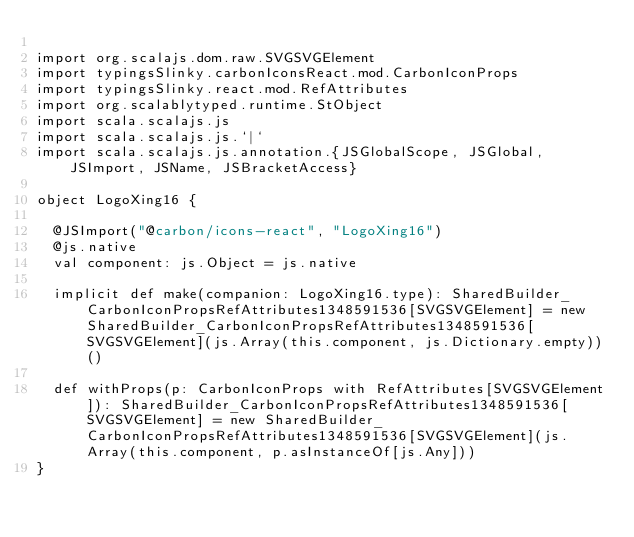Convert code to text. <code><loc_0><loc_0><loc_500><loc_500><_Scala_>
import org.scalajs.dom.raw.SVGSVGElement
import typingsSlinky.carbonIconsReact.mod.CarbonIconProps
import typingsSlinky.react.mod.RefAttributes
import org.scalablytyped.runtime.StObject
import scala.scalajs.js
import scala.scalajs.js.`|`
import scala.scalajs.js.annotation.{JSGlobalScope, JSGlobal, JSImport, JSName, JSBracketAccess}

object LogoXing16 {
  
  @JSImport("@carbon/icons-react", "LogoXing16")
  @js.native
  val component: js.Object = js.native
  
  implicit def make(companion: LogoXing16.type): SharedBuilder_CarbonIconPropsRefAttributes1348591536[SVGSVGElement] = new SharedBuilder_CarbonIconPropsRefAttributes1348591536[SVGSVGElement](js.Array(this.component, js.Dictionary.empty))()
  
  def withProps(p: CarbonIconProps with RefAttributes[SVGSVGElement]): SharedBuilder_CarbonIconPropsRefAttributes1348591536[SVGSVGElement] = new SharedBuilder_CarbonIconPropsRefAttributes1348591536[SVGSVGElement](js.Array(this.component, p.asInstanceOf[js.Any]))
}
</code> 